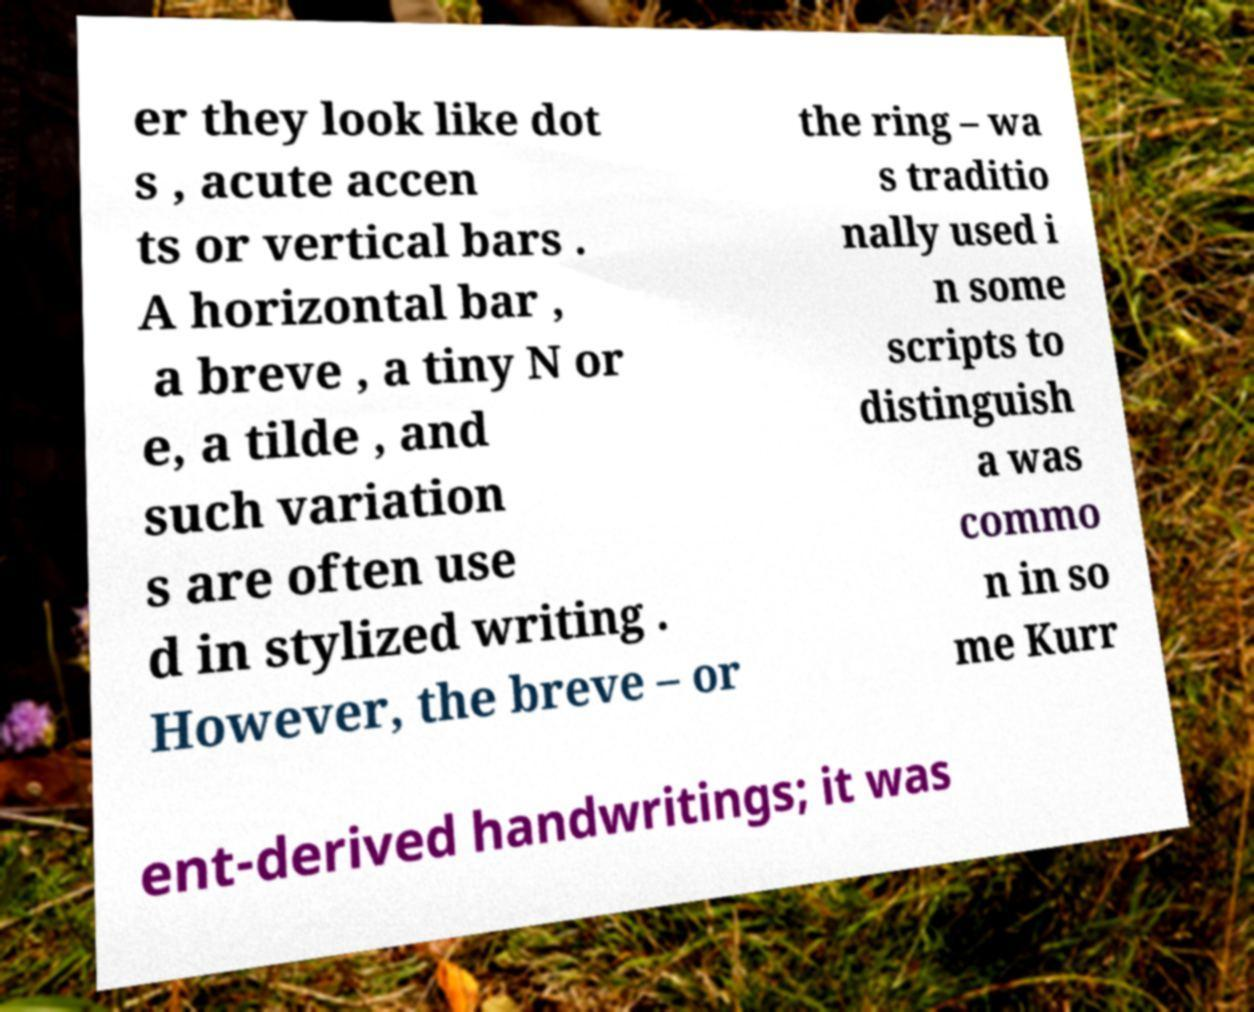What messages or text are displayed in this image? I need them in a readable, typed format. er they look like dot s , acute accen ts or vertical bars . A horizontal bar , a breve , a tiny N or e, a tilde , and such variation s are often use d in stylized writing . However, the breve – or the ring – wa s traditio nally used i n some scripts to distinguish a was commo n in so me Kurr ent-derived handwritings; it was 